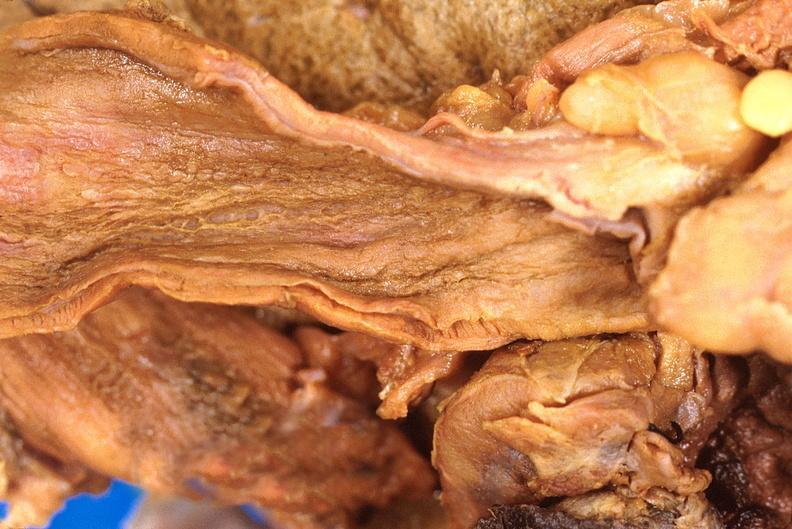s gastrointestinal present?
Answer the question using a single word or phrase. Yes 